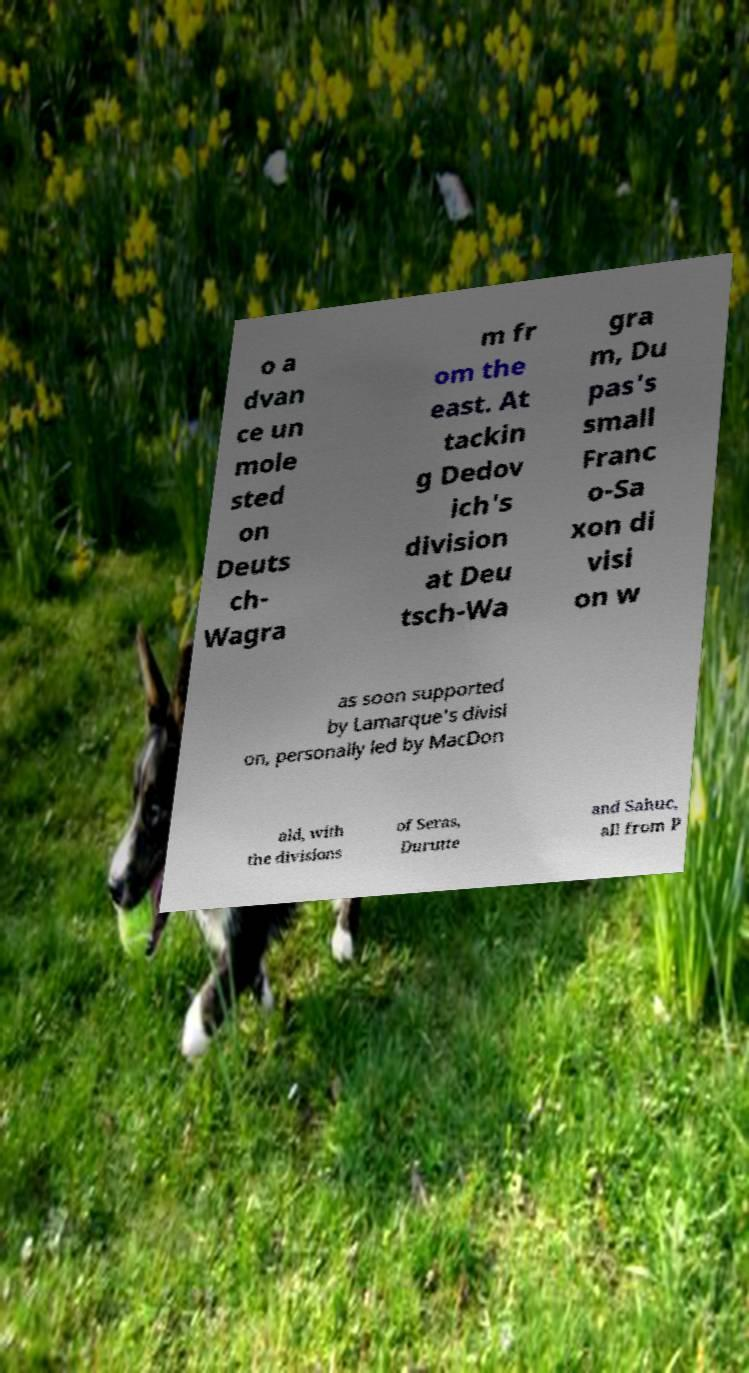Please identify and transcribe the text found in this image. o a dvan ce un mole sted on Deuts ch- Wagra m fr om the east. At tackin g Dedov ich's division at Deu tsch-Wa gra m, Du pas's small Franc o-Sa xon di visi on w as soon supported by Lamarque's divisi on, personally led by MacDon ald, with the divisions of Seras, Durutte and Sahuc, all from P 